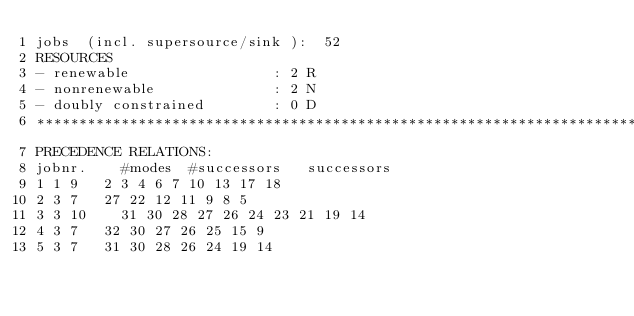Convert code to text. <code><loc_0><loc_0><loc_500><loc_500><_ObjectiveC_>jobs  (incl. supersource/sink ):	52
RESOURCES
- renewable                 : 2 R
- nonrenewable              : 2 N
- doubly constrained        : 0 D
************************************************************************
PRECEDENCE RELATIONS:
jobnr.    #modes  #successors   successors
1	1	9		2 3 4 6 7 10 13 17 18 
2	3	7		27 22 12 11 9 8 5 
3	3	10		31 30 28 27 26 24 23 21 19 14 
4	3	7		32 30 27 26 25 15 9 
5	3	7		31 30 28 26 24 19 14 </code> 